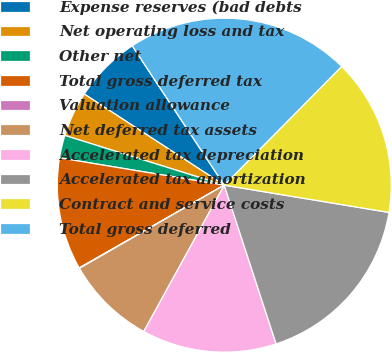Convert chart. <chart><loc_0><loc_0><loc_500><loc_500><pie_chart><fcel>Expense reserves (bad debts<fcel>Net operating loss and tax<fcel>Other net<fcel>Total gross deferred tax<fcel>Valuation allowance<fcel>Net deferred tax assets<fcel>Accelerated tax depreciation<fcel>Accelerated tax amortization<fcel>Contract and service costs<fcel>Total gross deferred<nl><fcel>6.53%<fcel>4.37%<fcel>2.2%<fcel>10.87%<fcel>0.04%<fcel>8.7%<fcel>13.03%<fcel>17.36%<fcel>15.2%<fcel>21.7%<nl></chart> 